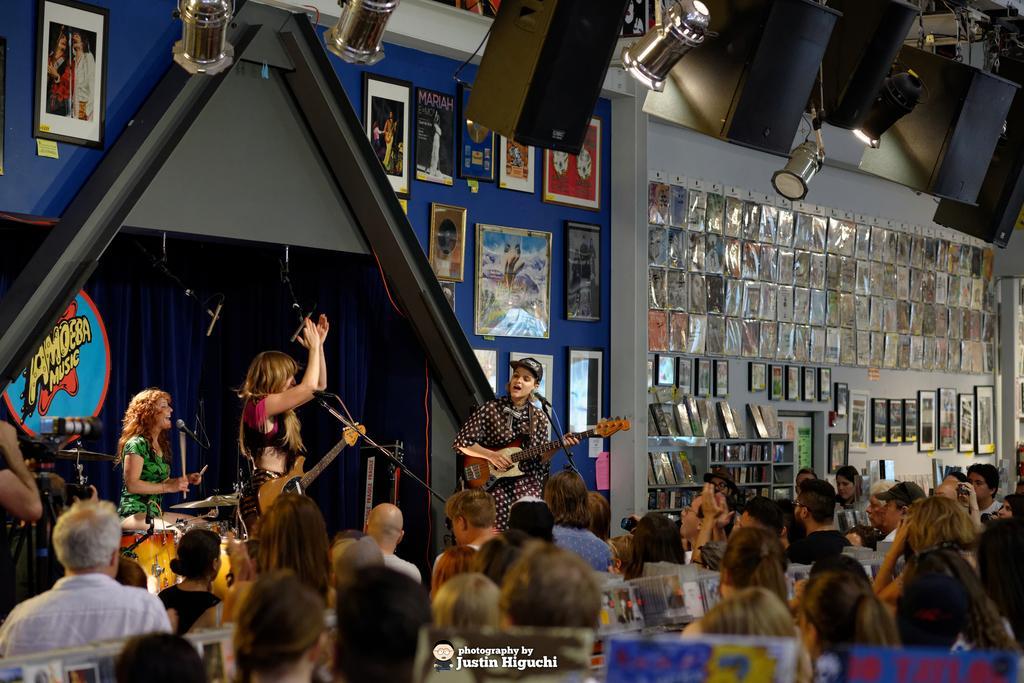How would you summarize this image in a sentence or two? In this picture we can see some group of people sitting on the chairs and in front of them there are three people holding some musical instruments and playing them and to the wall there are some frames and a lot of frames on the other side of the wall and there are some lights and speakers to the roof. 